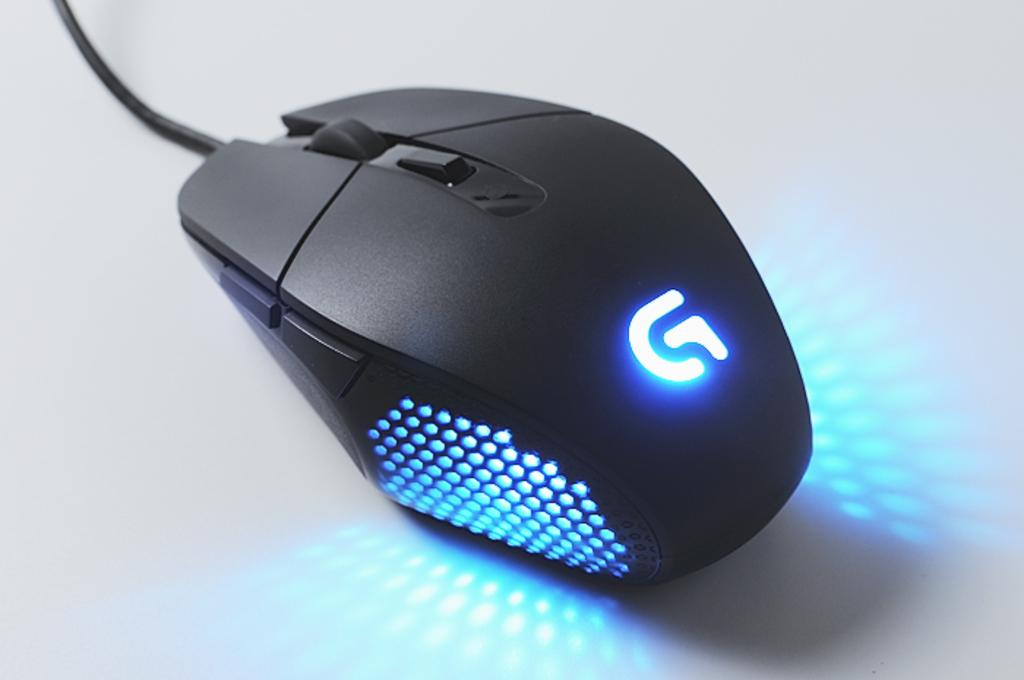<image>
Give a short and clear explanation of the subsequent image. A computer mouse lit up with the letter G glowing. 